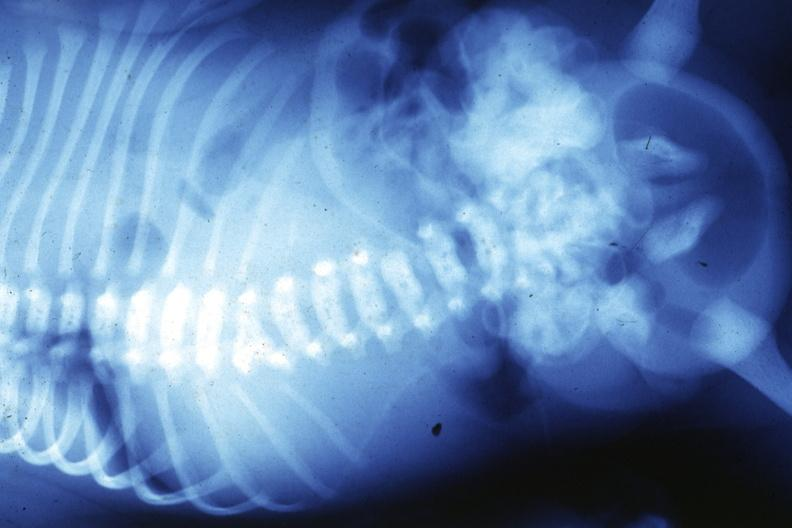what does this image show?
Answer the question using a single word or phrase. X-ray infant t12 lesion 